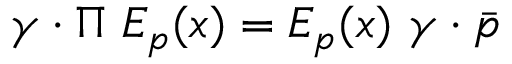<formula> <loc_0><loc_0><loc_500><loc_500>\gamma \cdot \Pi E _ { p } ( x ) = E _ { p } ( x ) \gamma \cdot \bar { p }</formula> 